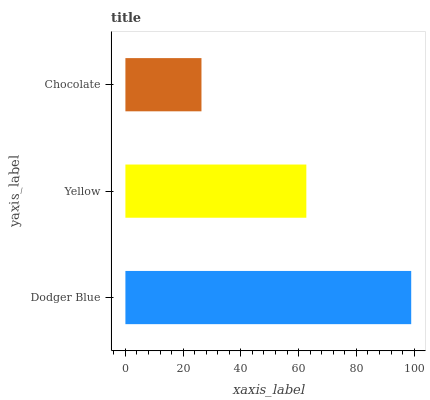Is Chocolate the minimum?
Answer yes or no. Yes. Is Dodger Blue the maximum?
Answer yes or no. Yes. Is Yellow the minimum?
Answer yes or no. No. Is Yellow the maximum?
Answer yes or no. No. Is Dodger Blue greater than Yellow?
Answer yes or no. Yes. Is Yellow less than Dodger Blue?
Answer yes or no. Yes. Is Yellow greater than Dodger Blue?
Answer yes or no. No. Is Dodger Blue less than Yellow?
Answer yes or no. No. Is Yellow the high median?
Answer yes or no. Yes. Is Yellow the low median?
Answer yes or no. Yes. Is Dodger Blue the high median?
Answer yes or no. No. Is Chocolate the low median?
Answer yes or no. No. 